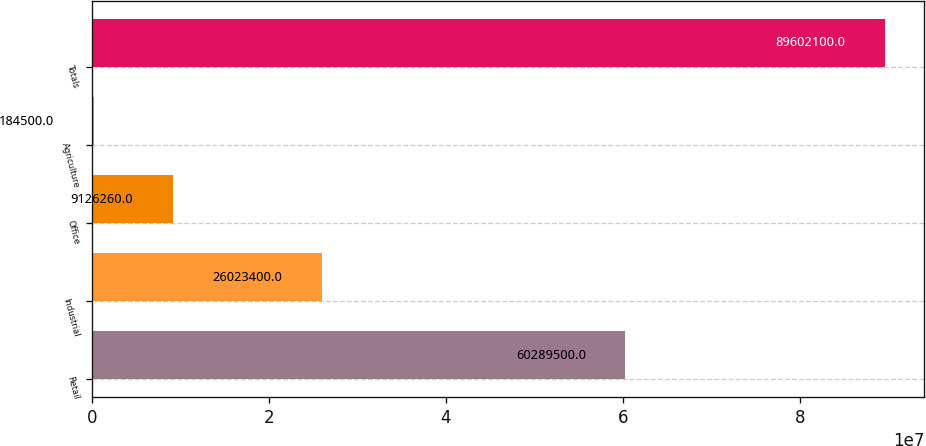Convert chart to OTSL. <chart><loc_0><loc_0><loc_500><loc_500><bar_chart><fcel>Retail<fcel>Industrial<fcel>Office<fcel>Agriculture<fcel>Totals<nl><fcel>6.02895e+07<fcel>2.60234e+07<fcel>9.12626e+06<fcel>184500<fcel>8.96021e+07<nl></chart> 